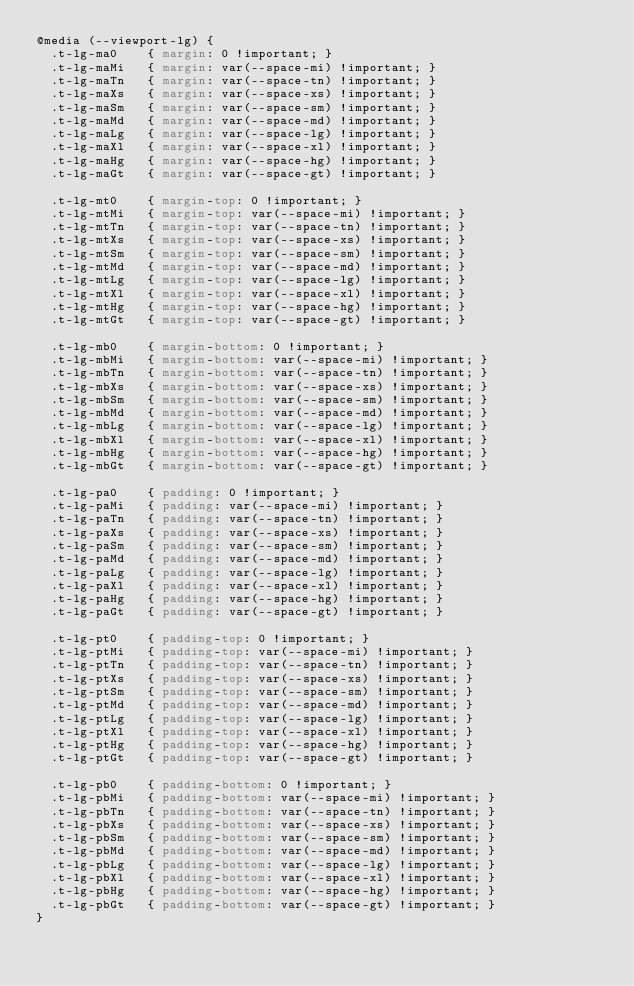Convert code to text. <code><loc_0><loc_0><loc_500><loc_500><_CSS_>@media (--viewport-lg) {
  .t-lg-ma0    { margin: 0 !important; }
  .t-lg-maMi   { margin: var(--space-mi) !important; }
  .t-lg-maTn   { margin: var(--space-tn) !important; }
  .t-lg-maXs   { margin: var(--space-xs) !important; }
  .t-lg-maSm   { margin: var(--space-sm) !important; }
  .t-lg-maMd   { margin: var(--space-md) !important; }
  .t-lg-maLg   { margin: var(--space-lg) !important; }
  .t-lg-maXl   { margin: var(--space-xl) !important; }
  .t-lg-maHg   { margin: var(--space-hg) !important; }
  .t-lg-maGt   { margin: var(--space-gt) !important; }

  .t-lg-mt0    { margin-top: 0 !important; }
  .t-lg-mtMi   { margin-top: var(--space-mi) !important; }
  .t-lg-mtTn   { margin-top: var(--space-tn) !important; }
  .t-lg-mtXs   { margin-top: var(--space-xs) !important; }
  .t-lg-mtSm   { margin-top: var(--space-sm) !important; }
  .t-lg-mtMd   { margin-top: var(--space-md) !important; }
  .t-lg-mtLg   { margin-top: var(--space-lg) !important; }
  .t-lg-mtXl   { margin-top: var(--space-xl) !important; }
  .t-lg-mtHg   { margin-top: var(--space-hg) !important; }
  .t-lg-mtGt   { margin-top: var(--space-gt) !important; }

  .t-lg-mb0    { margin-bottom: 0 !important; }
  .t-lg-mbMi   { margin-bottom: var(--space-mi) !important; }
  .t-lg-mbTn   { margin-bottom: var(--space-tn) !important; }
  .t-lg-mbXs   { margin-bottom: var(--space-xs) !important; }
  .t-lg-mbSm   { margin-bottom: var(--space-sm) !important; }
  .t-lg-mbMd   { margin-bottom: var(--space-md) !important; }
  .t-lg-mbLg   { margin-bottom: var(--space-lg) !important; }
  .t-lg-mbXl   { margin-bottom: var(--space-xl) !important; }
  .t-lg-mbHg   { margin-bottom: var(--space-hg) !important; }
  .t-lg-mbGt   { margin-bottom: var(--space-gt) !important; }

  .t-lg-pa0    { padding: 0 !important; }
  .t-lg-paMi   { padding: var(--space-mi) !important; }
  .t-lg-paTn   { padding: var(--space-tn) !important; }
  .t-lg-paXs   { padding: var(--space-xs) !important; }
  .t-lg-paSm   { padding: var(--space-sm) !important; }
  .t-lg-paMd   { padding: var(--space-md) !important; }
  .t-lg-paLg   { padding: var(--space-lg) !important; }
  .t-lg-paXl   { padding: var(--space-xl) !important; }
  .t-lg-paHg   { padding: var(--space-hg) !important; }
  .t-lg-paGt   { padding: var(--space-gt) !important; }

  .t-lg-pt0    { padding-top: 0 !important; }
  .t-lg-ptMi   { padding-top: var(--space-mi) !important; }
  .t-lg-ptTn   { padding-top: var(--space-tn) !important; }
  .t-lg-ptXs   { padding-top: var(--space-xs) !important; }
  .t-lg-ptSm   { padding-top: var(--space-sm) !important; }
  .t-lg-ptMd   { padding-top: var(--space-md) !important; }
  .t-lg-ptLg   { padding-top: var(--space-lg) !important; }
  .t-lg-ptXl   { padding-top: var(--space-xl) !important; }
  .t-lg-ptHg   { padding-top: var(--space-hg) !important; }
  .t-lg-ptGt   { padding-top: var(--space-gt) !important; }

  .t-lg-pb0    { padding-bottom: 0 !important; }
  .t-lg-pbMi   { padding-bottom: var(--space-mi) !important; }
  .t-lg-pbTn   { padding-bottom: var(--space-tn) !important; }
  .t-lg-pbXs   { padding-bottom: var(--space-xs) !important; }
  .t-lg-pbSm   { padding-bottom: var(--space-sm) !important; }
  .t-lg-pbMd   { padding-bottom: var(--space-md) !important; }
  .t-lg-pbLg   { padding-bottom: var(--space-lg) !important; }
  .t-lg-pbXl   { padding-bottom: var(--space-xl) !important; }
  .t-lg-pbHg   { padding-bottom: var(--space-hg) !important; }
  .t-lg-pbGt   { padding-bottom: var(--space-gt) !important; }
}
</code> 